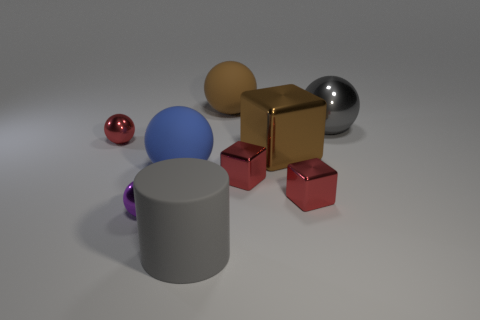How do you think the texture of the red cube compares to that of the purple ball? The red cube appears to have a matte texture with a slightly rough surface that diffuses light, giving it a soft look without distinct reflections. In contrast, the purple ball has a smoother but also matte finish, which reflects a small amount of light and gives it a subtle sheen. 